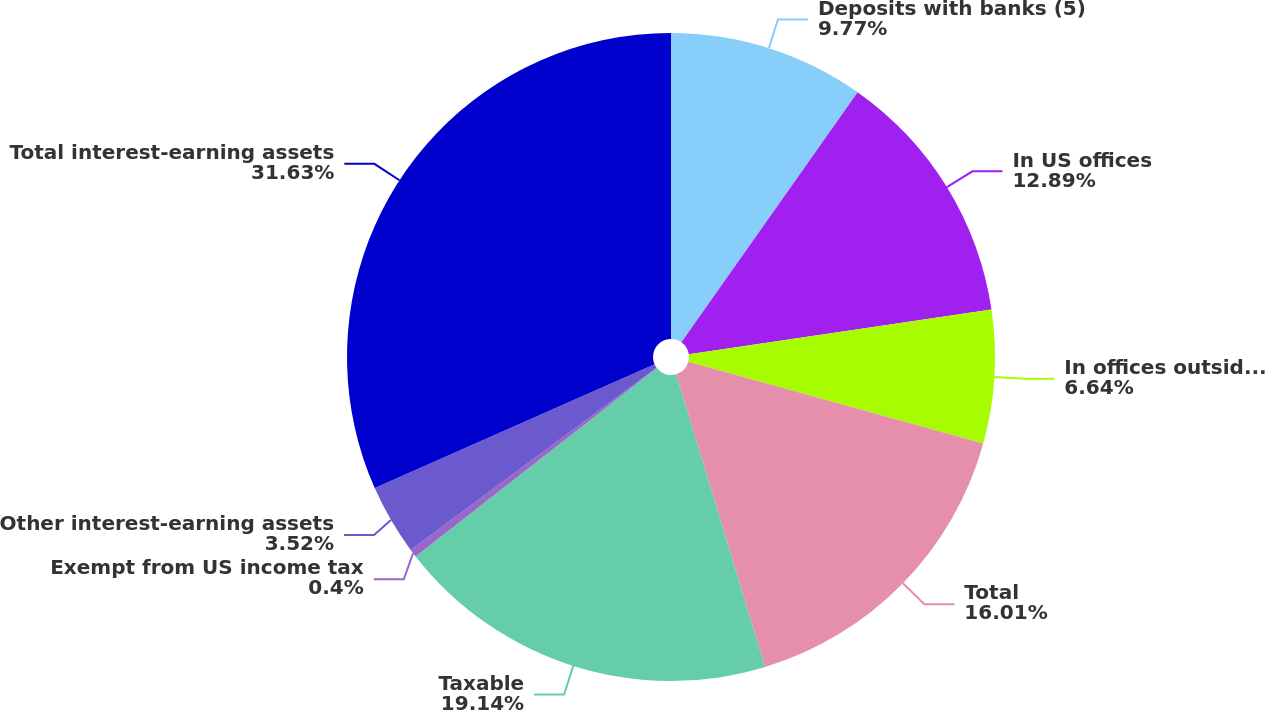Convert chart to OTSL. <chart><loc_0><loc_0><loc_500><loc_500><pie_chart><fcel>Deposits with banks (5)<fcel>In US offices<fcel>In offices outside the US (5)<fcel>Total<fcel>Taxable<fcel>Exempt from US income tax<fcel>Other interest-earning assets<fcel>Total interest-earning assets<nl><fcel>9.77%<fcel>12.89%<fcel>6.64%<fcel>16.01%<fcel>19.14%<fcel>0.4%<fcel>3.52%<fcel>31.63%<nl></chart> 